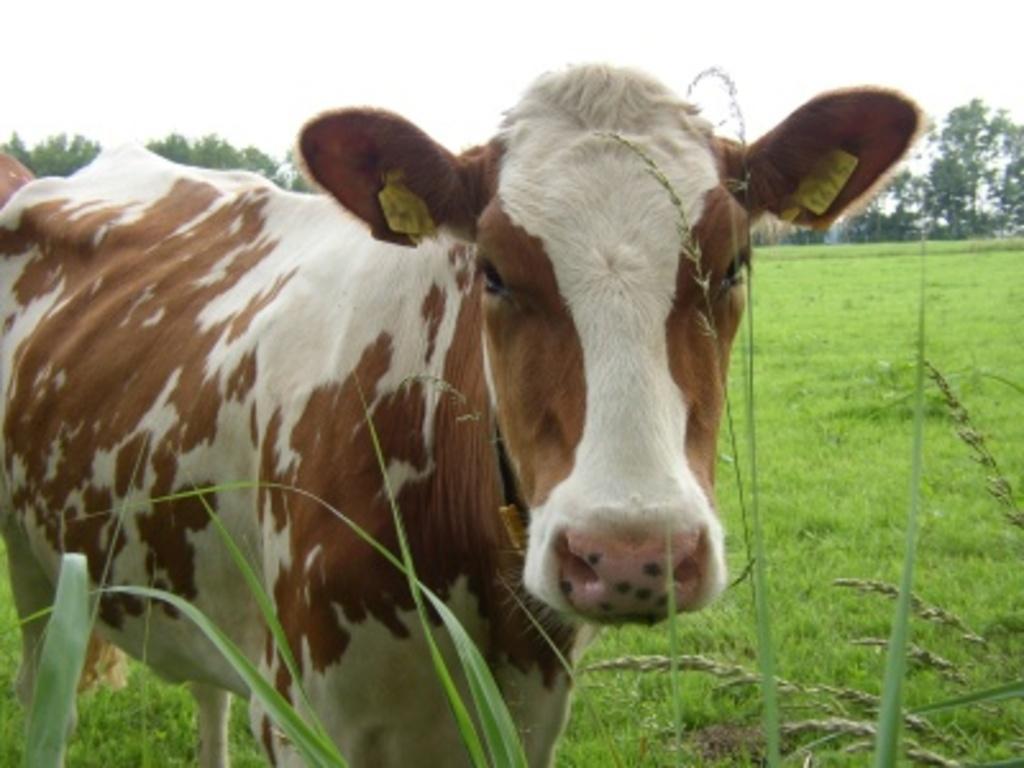Could you give a brief overview of what you see in this image? In this image I can see an animal which is in white and brown color. It is on the grass. In the background I can see many trees and the sky. 